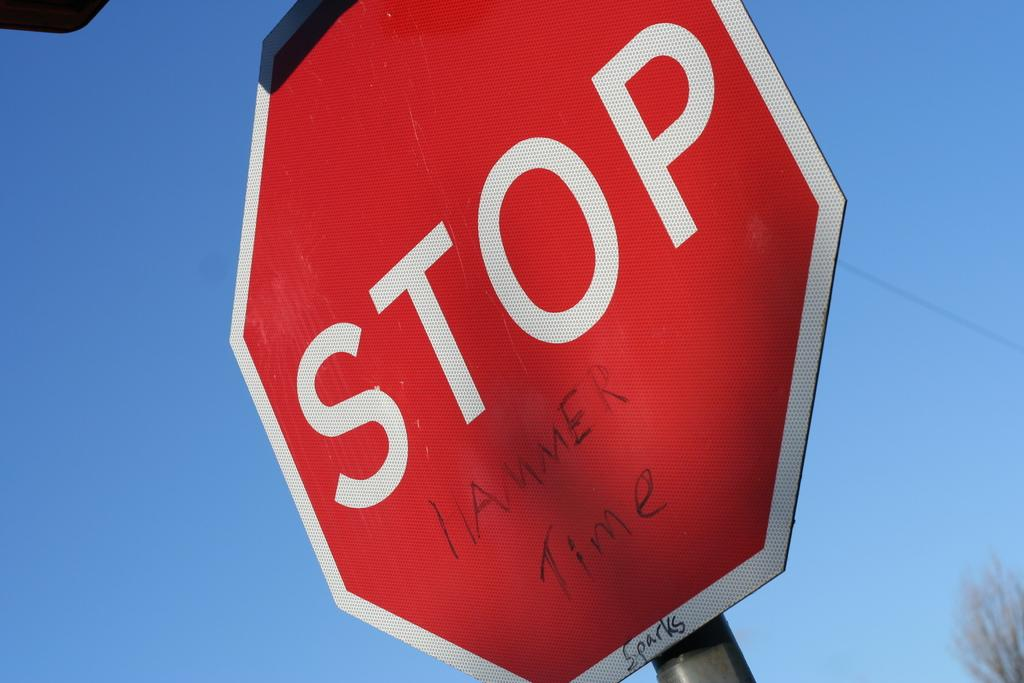Provide a one-sentence caption for the provided image. The words hammer time are written on a stop sign. 